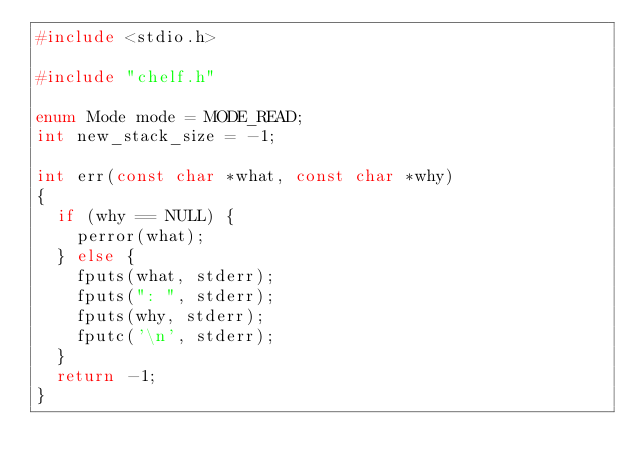Convert code to text. <code><loc_0><loc_0><loc_500><loc_500><_C_>#include <stdio.h>

#include "chelf.h"

enum Mode mode = MODE_READ;
int new_stack_size = -1;

int err(const char *what, const char *why)
{
	if (why == NULL) {
		perror(what);
	} else {
		fputs(what, stderr);
		fputs(": ", stderr);
		fputs(why, stderr);
		fputc('\n', stderr);
	}
	return -1;
}

</code> 